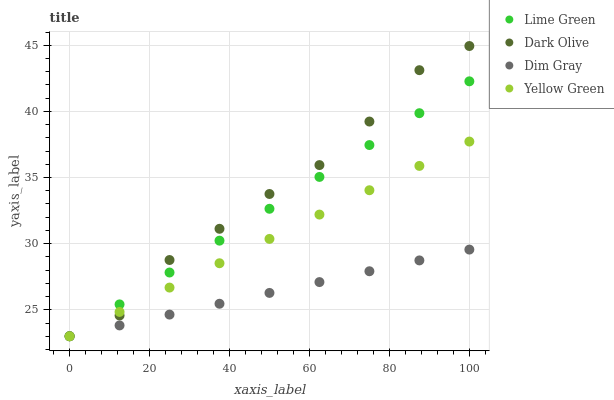Does Dim Gray have the minimum area under the curve?
Answer yes or no. Yes. Does Dark Olive have the maximum area under the curve?
Answer yes or no. Yes. Does Lime Green have the minimum area under the curve?
Answer yes or no. No. Does Lime Green have the maximum area under the curve?
Answer yes or no. No. Is Dim Gray the smoothest?
Answer yes or no. Yes. Is Dark Olive the roughest?
Answer yes or no. Yes. Is Lime Green the smoothest?
Answer yes or no. No. Is Lime Green the roughest?
Answer yes or no. No. Does Dim Gray have the lowest value?
Answer yes or no. Yes. Does Dark Olive have the highest value?
Answer yes or no. Yes. Does Lime Green have the highest value?
Answer yes or no. No. Does Yellow Green intersect Lime Green?
Answer yes or no. Yes. Is Yellow Green less than Lime Green?
Answer yes or no. No. Is Yellow Green greater than Lime Green?
Answer yes or no. No. 